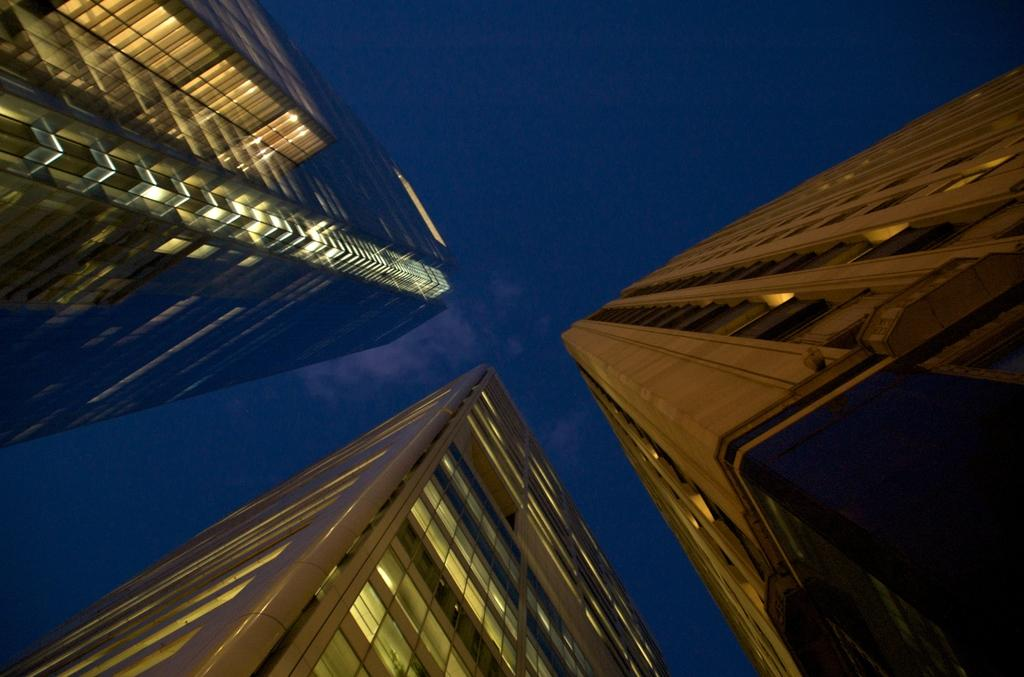What type of structures are visible in the image? There are buildings with lights in the image. What can be seen in the background of the image? The background of the image includes the blue sky. How many drawers are visible in the image? There are no drawers present in the image. What type of wing is visible in the image? There is no wing present in the image. 